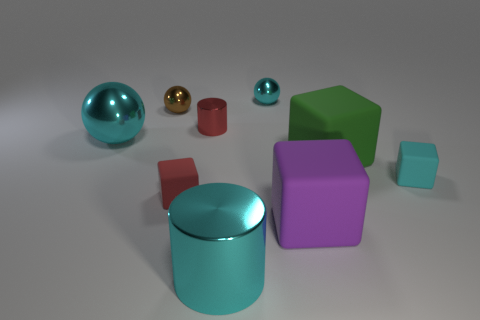Subtract all cyan spheres. How many spheres are left? 1 Subtract all cyan balls. How many balls are left? 1 Subtract 0 purple balls. How many objects are left? 9 Subtract all balls. How many objects are left? 6 Subtract 1 cubes. How many cubes are left? 3 Subtract all green cylinders. Subtract all blue balls. How many cylinders are left? 2 Subtract all cyan spheres. How many red cylinders are left? 1 Subtract all green blocks. Subtract all red objects. How many objects are left? 6 Add 4 small blocks. How many small blocks are left? 6 Add 1 red things. How many red things exist? 3 